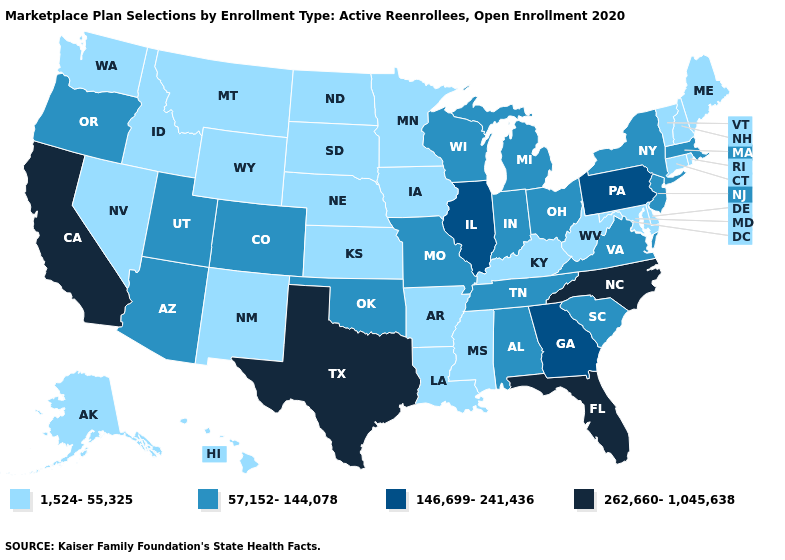What is the highest value in states that border Washington?
Keep it brief. 57,152-144,078. Is the legend a continuous bar?
Answer briefly. No. Among the states that border Kansas , does Oklahoma have the lowest value?
Quick response, please. No. Among the states that border California , which have the highest value?
Short answer required. Arizona, Oregon. What is the value of Illinois?
Answer briefly. 146,699-241,436. Among the states that border Nevada , does Utah have the lowest value?
Give a very brief answer. No. Among the states that border North Carolina , which have the highest value?
Short answer required. Georgia. Is the legend a continuous bar?
Answer briefly. No. Name the states that have a value in the range 146,699-241,436?
Quick response, please. Georgia, Illinois, Pennsylvania. Among the states that border Florida , does Alabama have the highest value?
Write a very short answer. No. Name the states that have a value in the range 57,152-144,078?
Answer briefly. Alabama, Arizona, Colorado, Indiana, Massachusetts, Michigan, Missouri, New Jersey, New York, Ohio, Oklahoma, Oregon, South Carolina, Tennessee, Utah, Virginia, Wisconsin. Which states hav the highest value in the Northeast?
Concise answer only. Pennsylvania. What is the highest value in states that border Colorado?
Answer briefly. 57,152-144,078. Does Maryland have the lowest value in the South?
Quick response, please. Yes. Name the states that have a value in the range 262,660-1,045,638?
Keep it brief. California, Florida, North Carolina, Texas. 